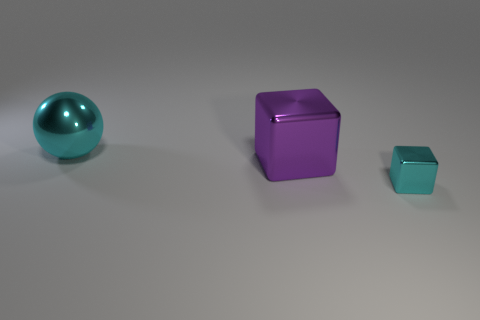Add 1 blue cubes. How many objects exist? 4 Add 1 shiny balls. How many shiny balls exist? 2 Subtract all cyan cubes. How many cubes are left? 1 Subtract 0 yellow balls. How many objects are left? 3 Subtract all balls. How many objects are left? 2 Subtract all yellow blocks. Subtract all blue cylinders. How many blocks are left? 2 Subtract all gray cylinders. How many purple blocks are left? 1 Subtract all tiny blue cubes. Subtract all metallic things. How many objects are left? 0 Add 2 big cyan metal balls. How many big cyan metal balls are left? 3 